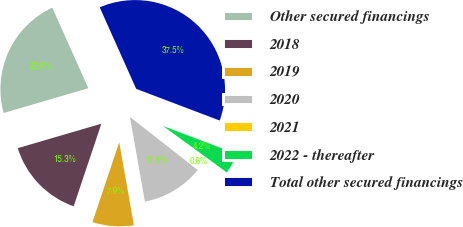Convert chart. <chart><loc_0><loc_0><loc_500><loc_500><pie_chart><fcel>Other secured financings<fcel>2018<fcel>2019<fcel>2020<fcel>2021<fcel>2022 - thereafter<fcel>Total other secured financings<nl><fcel>22.83%<fcel>15.32%<fcel>7.94%<fcel>11.63%<fcel>0.56%<fcel>4.25%<fcel>37.47%<nl></chart> 